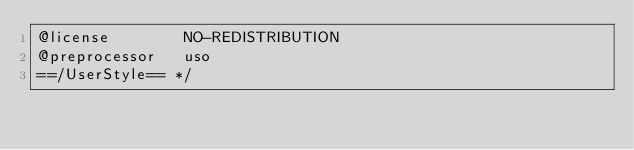<code> <loc_0><loc_0><loc_500><loc_500><_CSS_>@license        NO-REDISTRIBUTION
@preprocessor   uso
==/UserStyle== */</code> 